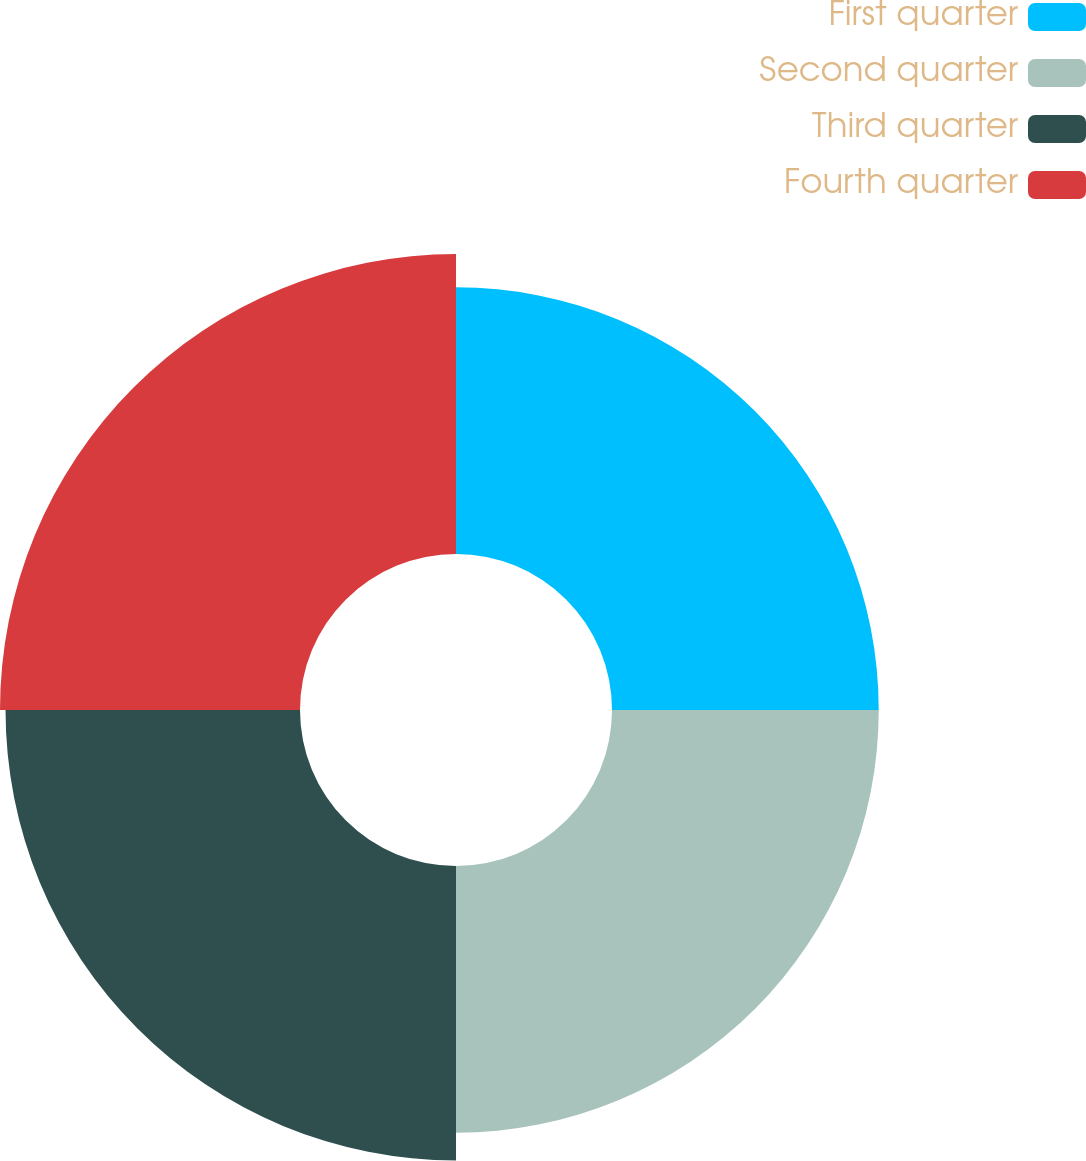Convert chart. <chart><loc_0><loc_0><loc_500><loc_500><pie_chart><fcel>First quarter<fcel>Second quarter<fcel>Third quarter<fcel>Fourth quarter<nl><fcel>23.65%<fcel>23.65%<fcel>26.11%<fcel>26.6%<nl></chart> 